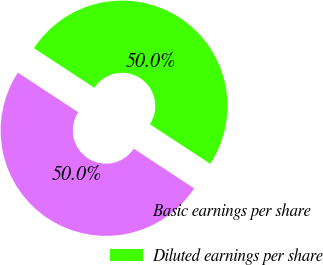<chart> <loc_0><loc_0><loc_500><loc_500><pie_chart><fcel>Basic earnings per share<fcel>Diluted earnings per share<nl><fcel>50.0%<fcel>50.0%<nl></chart> 